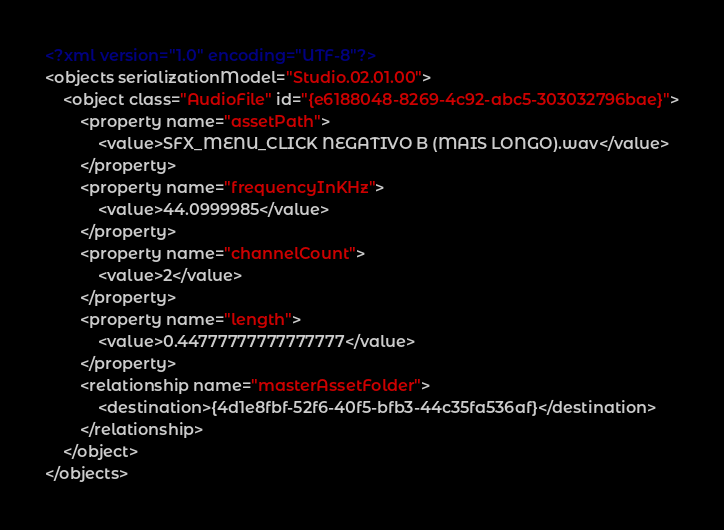<code> <loc_0><loc_0><loc_500><loc_500><_XML_><?xml version="1.0" encoding="UTF-8"?>
<objects serializationModel="Studio.02.01.00">
	<object class="AudioFile" id="{e6188048-8269-4c92-abc5-303032796bae}">
		<property name="assetPath">
			<value>SFX_MENU_CLICK NEGATIVO B (MAIS LONGO).wav</value>
		</property>
		<property name="frequencyInKHz">
			<value>44.0999985</value>
		</property>
		<property name="channelCount">
			<value>2</value>
		</property>
		<property name="length">
			<value>0.44777777777777777</value>
		</property>
		<relationship name="masterAssetFolder">
			<destination>{4d1e8fbf-52f6-40f5-bfb3-44c35fa536af}</destination>
		</relationship>
	</object>
</objects>
</code> 